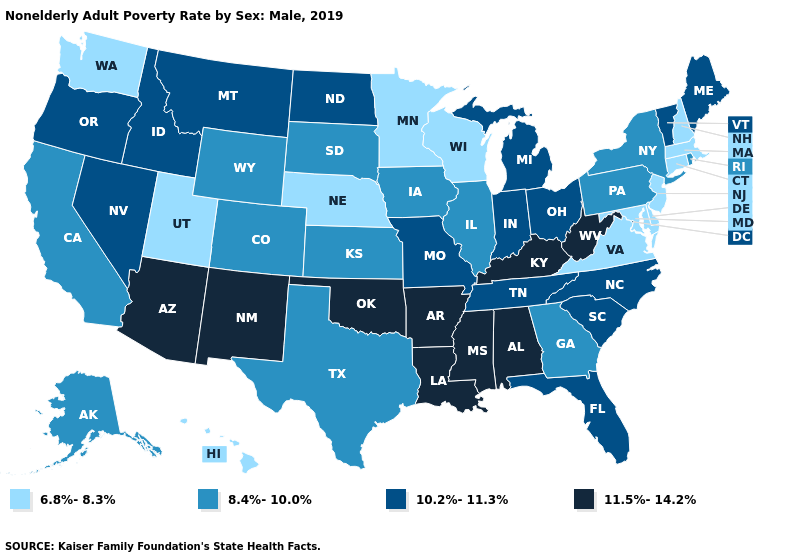What is the value of California?
Give a very brief answer. 8.4%-10.0%. What is the lowest value in the USA?
Concise answer only. 6.8%-8.3%. Among the states that border Oregon , which have the lowest value?
Keep it brief. Washington. Name the states that have a value in the range 10.2%-11.3%?
Concise answer only. Florida, Idaho, Indiana, Maine, Michigan, Missouri, Montana, Nevada, North Carolina, North Dakota, Ohio, Oregon, South Carolina, Tennessee, Vermont. What is the lowest value in the MidWest?
Be succinct. 6.8%-8.3%. What is the value of West Virginia?
Write a very short answer. 11.5%-14.2%. Name the states that have a value in the range 6.8%-8.3%?
Write a very short answer. Connecticut, Delaware, Hawaii, Maryland, Massachusetts, Minnesota, Nebraska, New Hampshire, New Jersey, Utah, Virginia, Washington, Wisconsin. How many symbols are there in the legend?
Write a very short answer. 4. Among the states that border Arkansas , does Louisiana have the highest value?
Quick response, please. Yes. Does Maine have the same value as Alaska?
Write a very short answer. No. What is the value of Wisconsin?
Short answer required. 6.8%-8.3%. Among the states that border Oklahoma , does Arkansas have the highest value?
Answer briefly. Yes. What is the highest value in the Northeast ?
Write a very short answer. 10.2%-11.3%. Among the states that border Michigan , which have the lowest value?
Concise answer only. Wisconsin. What is the value of Wyoming?
Short answer required. 8.4%-10.0%. 